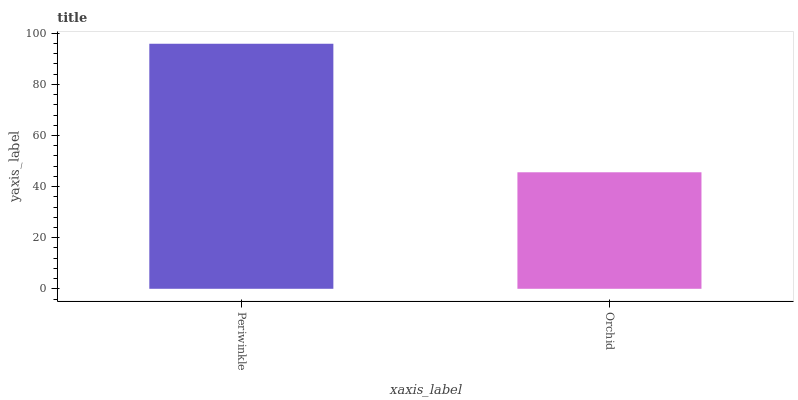Is Orchid the maximum?
Answer yes or no. No. Is Periwinkle greater than Orchid?
Answer yes or no. Yes. Is Orchid less than Periwinkle?
Answer yes or no. Yes. Is Orchid greater than Periwinkle?
Answer yes or no. No. Is Periwinkle less than Orchid?
Answer yes or no. No. Is Periwinkle the high median?
Answer yes or no. Yes. Is Orchid the low median?
Answer yes or no. Yes. Is Orchid the high median?
Answer yes or no. No. Is Periwinkle the low median?
Answer yes or no. No. 